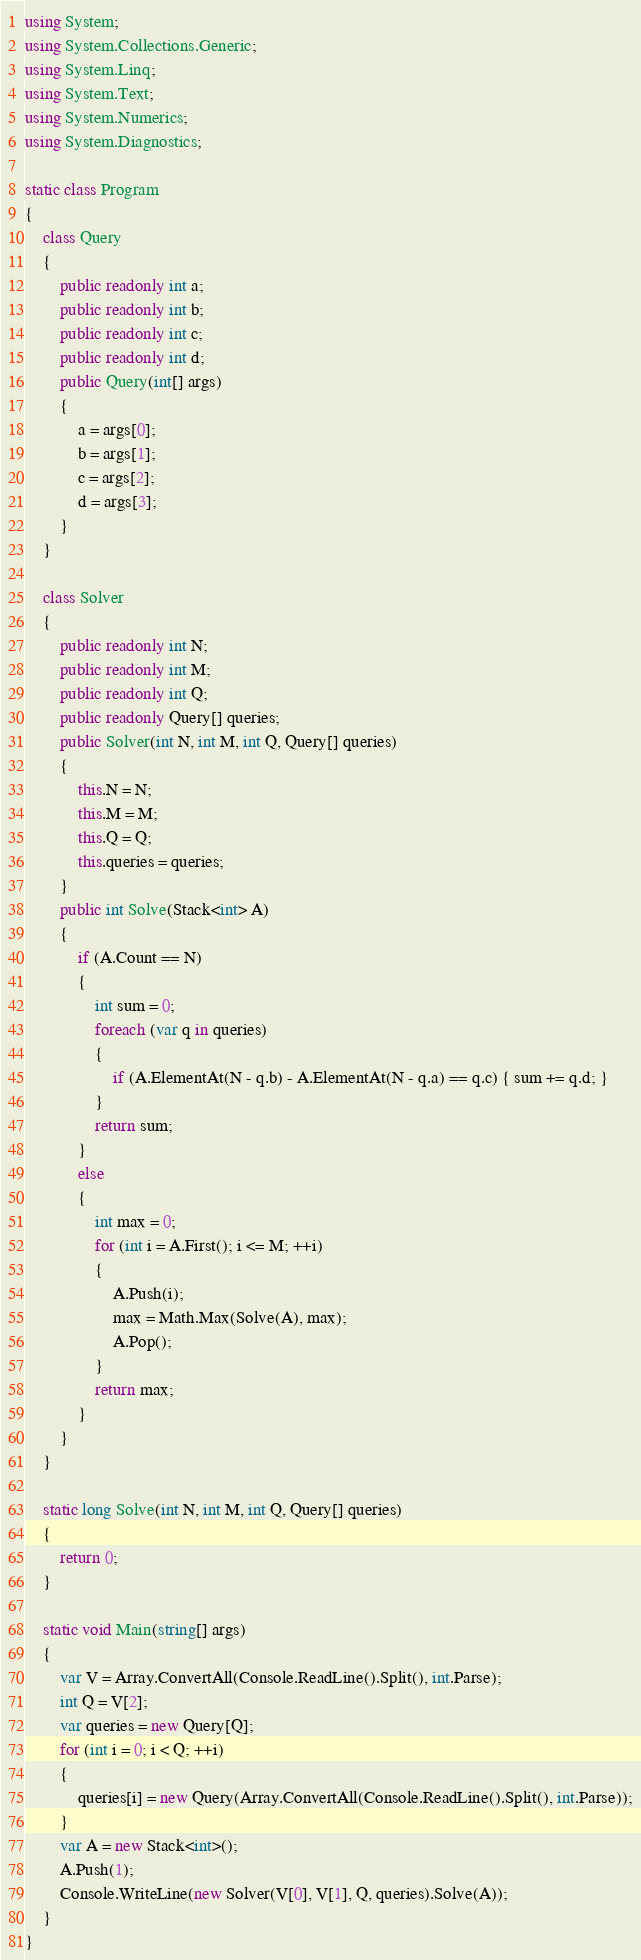<code> <loc_0><loc_0><loc_500><loc_500><_C#_>using System;
using System.Collections.Generic;
using System.Linq;
using System.Text;
using System.Numerics;
using System.Diagnostics;

static class Program
{
    class Query
    {
        public readonly int a;
        public readonly int b;
        public readonly int c;
        public readonly int d;
        public Query(int[] args)
        {
            a = args[0];
            b = args[1];
            c = args[2];
            d = args[3];
        }
    }

    class Solver
    {
        public readonly int N;
        public readonly int M;
        public readonly int Q;
        public readonly Query[] queries;
        public Solver(int N, int M, int Q, Query[] queries)
        {
            this.N = N;
            this.M = M;
            this.Q = Q;
            this.queries = queries;
        }
        public int Solve(Stack<int> A)
        {
            if (A.Count == N)
            {
                int sum = 0;
                foreach (var q in queries)
                {
                    if (A.ElementAt(N - q.b) - A.ElementAt(N - q.a) == q.c) { sum += q.d; }
                }
                return sum;
            }
            else
            {
                int max = 0;
                for (int i = A.First(); i <= M; ++i)
                {
                    A.Push(i);
                    max = Math.Max(Solve(A), max);
                    A.Pop();
                }
                return max;
            }
        }
    }

    static long Solve(int N, int M, int Q, Query[] queries)
    {
        return 0;
    }

    static void Main(string[] args)
    {
        var V = Array.ConvertAll(Console.ReadLine().Split(), int.Parse);
        int Q = V[2];
        var queries = new Query[Q];
        for (int i = 0; i < Q; ++i)
        {
            queries[i] = new Query(Array.ConvertAll(Console.ReadLine().Split(), int.Parse));
        }
        var A = new Stack<int>();
        A.Push(1);
        Console.WriteLine(new Solver(V[0], V[1], Q, queries).Solve(A));
    }
}
</code> 